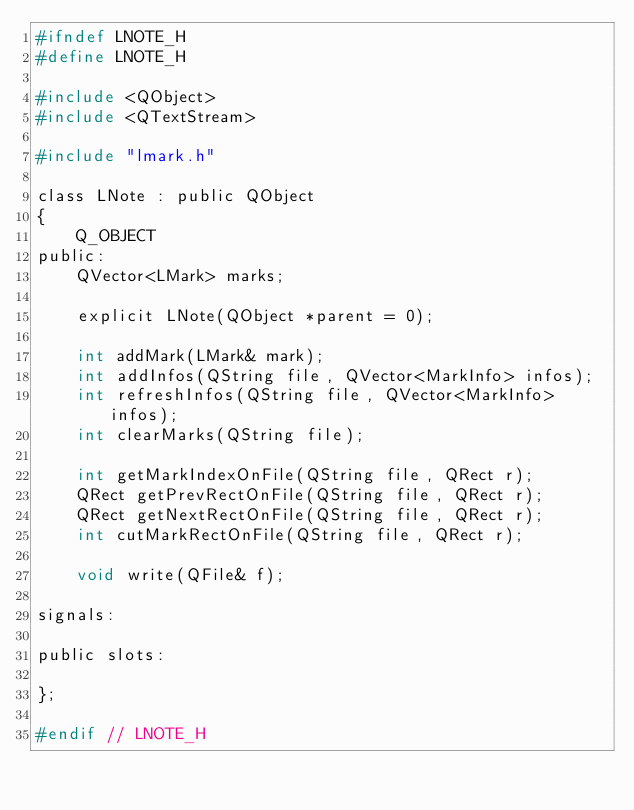Convert code to text. <code><loc_0><loc_0><loc_500><loc_500><_C_>#ifndef LNOTE_H
#define LNOTE_H

#include <QObject>
#include <QTextStream>

#include "lmark.h"

class LNote : public QObject
{
    Q_OBJECT
public:
    QVector<LMark> marks;

    explicit LNote(QObject *parent = 0);

    int addMark(LMark& mark);
    int addInfos(QString file, QVector<MarkInfo> infos);
    int refreshInfos(QString file, QVector<MarkInfo> infos);
    int clearMarks(QString file);

    int getMarkIndexOnFile(QString file, QRect r);
    QRect getPrevRectOnFile(QString file, QRect r);
    QRect getNextRectOnFile(QString file, QRect r);
    int cutMarkRectOnFile(QString file, QRect r);

    void write(QFile& f);
    
signals:
    
public slots:
    
};

#endif // LNOTE_H
</code> 